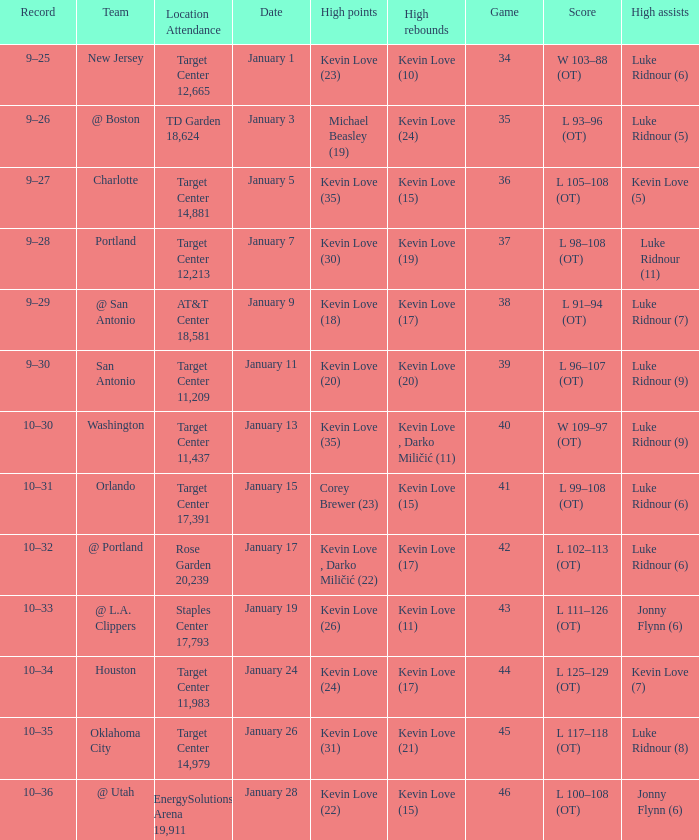How many times did kevin love (22) have the high points? 1.0. 